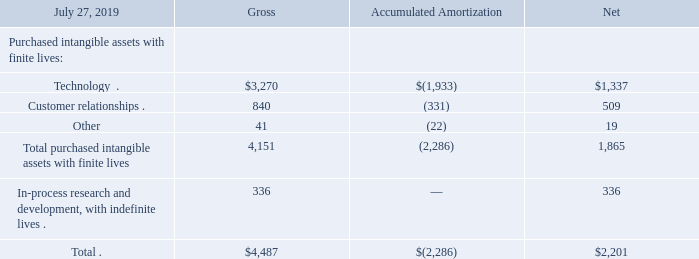5. Goodwill and Purchased Intangible Assets
(b) Purchased Intangible Assets
The following tables present details of our purchased intangible assets (in millions):
Purchased intangible assets include intangible assets acquired through acquisitions as well as through direct purchases or licenses.
Impairment charges related to purchased intangible assets were approximately $47 million for fiscal 2017. Impairment charges were as a result of declines in estimated fair value resulting from the reduction or elimination of expected future cash flows associated with certain of our technology and IPR&D intangible assets.
What did purchased intangible assets include? Intangible assets acquired through acquisitions as well as through direct purchases or licenses. How much were the impairment charges related to purchased intangible assets for fiscal 2017?
Answer scale should be: million. $47 million. What was the amount of gross purchased technology?
Answer scale should be: million. 3,270. What was the difference in the net values between Technology and Customer relationships?
Answer scale should be: million. 1,337-509
Answer: 828. How many Purchased intangible assets with finite lives had a gross amount that exceeded $1,000 million? Technology
Answer: 1. What was the difference between the gross total and net total for all purchased intangible assets?
Answer scale should be: million. 4,487-2,201
Answer: 2286. 